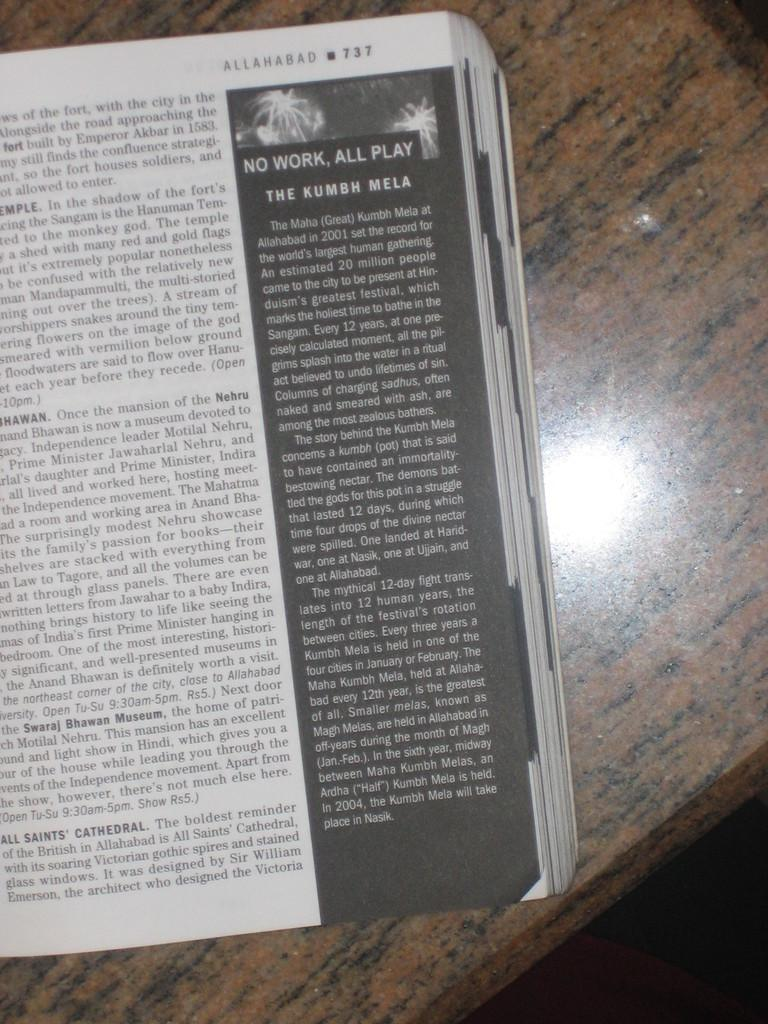Provide a one-sentence caption for the provided image. a book open to a page reading "No Work, All Play". 